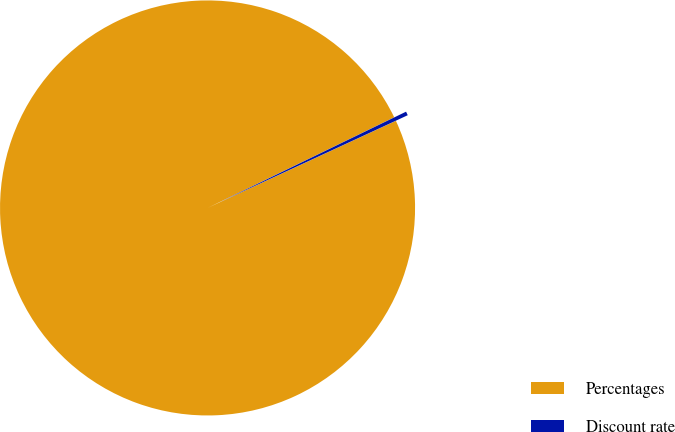<chart> <loc_0><loc_0><loc_500><loc_500><pie_chart><fcel>Percentages<fcel>Discount rate<nl><fcel>99.7%<fcel>0.3%<nl></chart> 